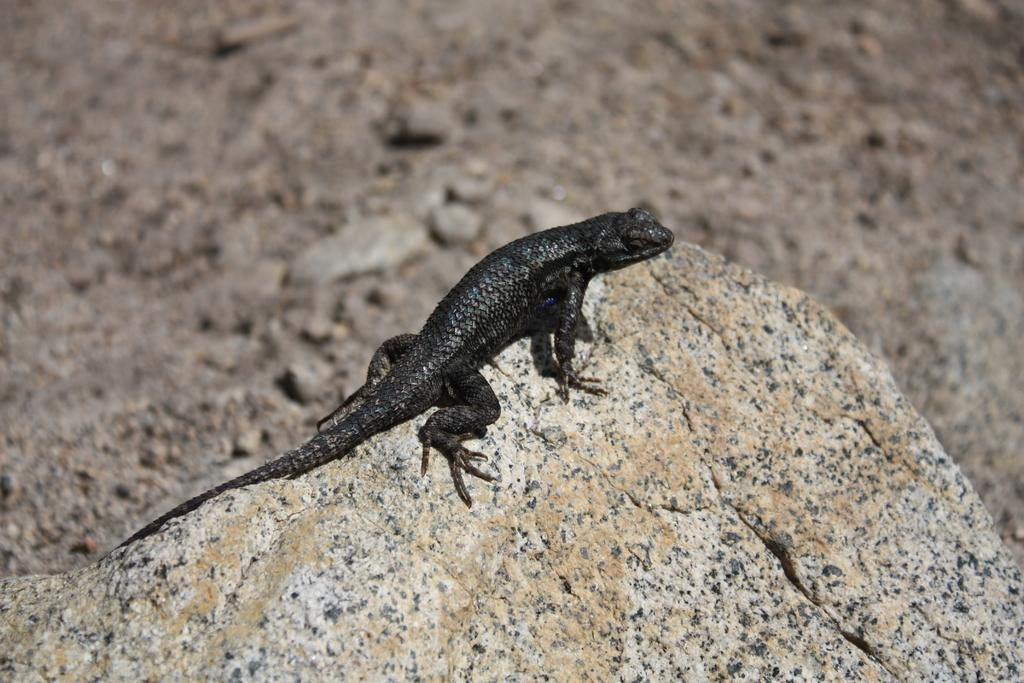What type of animal is in the image? There is a lizard in the image. What color is the lizard? The lizard is black in color. What surface is the lizard on? The lizard is on a stone. How much does the girl weigh in the image? There is no girl present in the image, so it is not possible to determine her weight. 